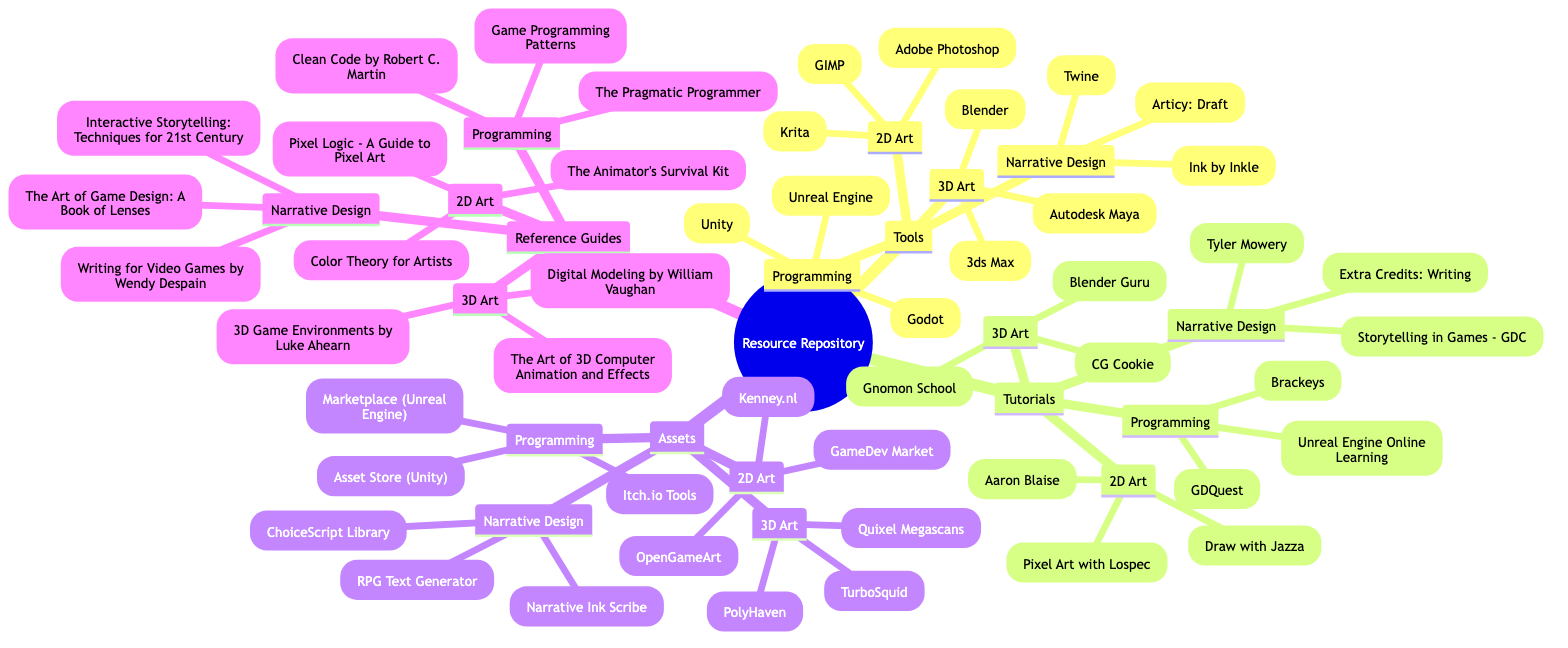What are the sub-categories under Tools in the diagram? The Tools category has four sub-categories, which are 2D Art, 3D Art, Programming, and Narrative Design. These can be systematically identified by examining the branches extending from the Tools node.
Answer: 2D Art, 3D Art, Programming, Narrative Design How many tutorials are listed under Programming? In the Programming sub-category under Tutorials, there are three tutorials mentioned: Brackeys, Unreal Engine Online Learning, and GDQuest. Counting these, we find the total.
Answer: 3 What is one tool for 3D Art according to the diagram? The 3D Art sub-category lists several tools. One of them is Blender. By identifying an item directly from the listed tools, we get the answer.
Answer: Blender Which category contains the tutorial "Extra Credits: Writing"? "Extra Credits: Writing" is found under the Narrative Design sub-category within Tutorials. By navigating the branches of the diagram, we determine its location.
Answer: Narrative Design How many assets are listed under 2D Art? In the 2D Art sub-category of Assets, there are three resources mentioned: Kenney.nl, OpenGameArt, and GameDev Market. We arrive at the total by counting these listed items.
Answer: 3 What type of guides can you find under Reference Guides for 3D Art? The 3D Art section of Reference Guides includes Digital Modeling by William Vaughan, The Art of 3D Computer Animation and Effects, and 3D Game Environments by Luke Ahearn. Identifying these items gives us the answer.
Answer: Digital Modeling by William Vaughan, The Art of 3D Computer Animation and Effects, 3D Game Environments by Luke Ahearn Is "Unity" found in the Narrative Design tools? "Unity" is listed under the Programming sub-category of Tools, not Narrative Design. Checking the specific nodes can confirm which items are listed under each sub-category.
Answer: No Which tutorial under 2D Art is taught by Aaron Blaise? The tutorial "Aaron Blaise" appears explicitly listed in the 2D Art section of Tutorials. Identifying the specific item answers the question succinctly.
Answer: Aaron Blaise How many assets are mentioned under the category of Narrative Design? Under Assets for Narrative Design, there are three entries: Narrative Ink Scribe, ChoiceScript Library, and RPG Text Generator. We determine this total by counting the listed assets under that specific category.
Answer: 3 